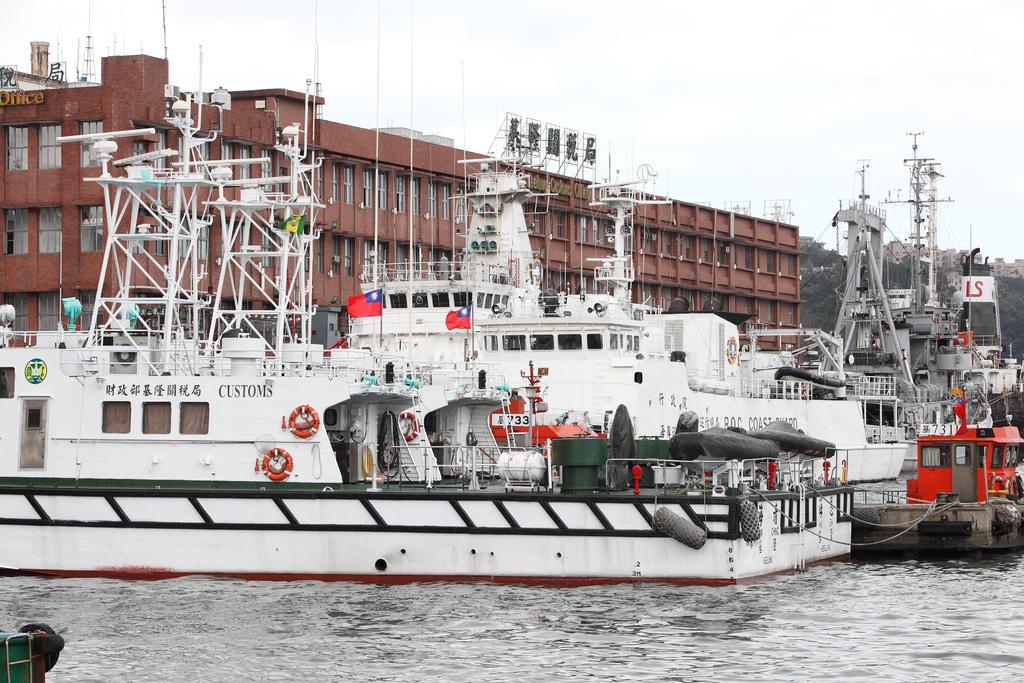In one or two sentences, can you explain what this image depicts? In this image it seems like a ship harbor in which there are so many shift in the water. In the background there is a building. At the top of the building there is a hoarding. At the top there is the sky. At the bottom there is water. In the ships there are so many poles,motors,life jackets in it. 